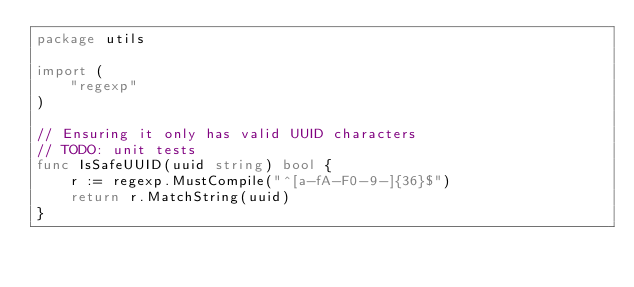Convert code to text. <code><loc_0><loc_0><loc_500><loc_500><_Go_>package utils

import (
	"regexp"
)

// Ensuring it only has valid UUID characters
// TODO: unit tests
func IsSafeUUID(uuid string) bool {
	r := regexp.MustCompile("^[a-fA-F0-9-]{36}$")
	return r.MatchString(uuid)
}
</code> 